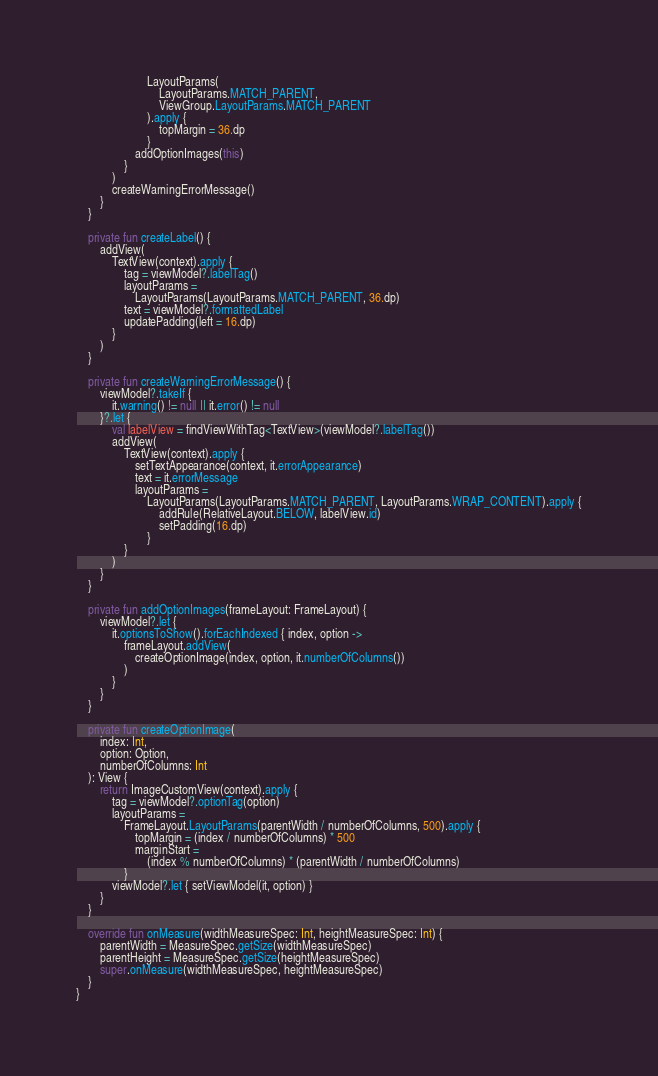Convert code to text. <code><loc_0><loc_0><loc_500><loc_500><_Kotlin_>                        LayoutParams(
                            LayoutParams.MATCH_PARENT,
                            ViewGroup.LayoutParams.MATCH_PARENT
                        ).apply {
                            topMargin = 36.dp
                        }
                    addOptionImages(this)
                }
            )
            createWarningErrorMessage()
        }
    }

    private fun createLabel() {
        addView(
            TextView(context).apply {
                tag = viewModel?.labelTag()
                layoutParams =
                    LayoutParams(LayoutParams.MATCH_PARENT, 36.dp)
                text = viewModel?.formattedLabel
                updatePadding(left = 16.dp)
            }
        )
    }

    private fun createWarningErrorMessage() {
        viewModel?.takeIf {
            it.warning() != null || it.error() != null
        }?.let {
            val labelView = findViewWithTag<TextView>(viewModel?.labelTag())
            addView(
                TextView(context).apply {
                    setTextAppearance(context, it.errorAppearance)
                    text = it.errorMessage
                    layoutParams =
                        LayoutParams(LayoutParams.MATCH_PARENT, LayoutParams.WRAP_CONTENT).apply {
                            addRule(RelativeLayout.BELOW, labelView.id)
                            setPadding(16.dp)
                        }
                }
            )
        }
    }

    private fun addOptionImages(frameLayout: FrameLayout) {
        viewModel?.let {
            it.optionsToShow().forEachIndexed { index, option ->
                frameLayout.addView(
                    createOptionImage(index, option, it.numberOfColumns())
                )
            }
        }
    }

    private fun createOptionImage(
        index: Int,
        option: Option,
        numberOfColumns: Int
    ): View {
        return ImageCustomView(context).apply {
            tag = viewModel?.optionTag(option)
            layoutParams =
                FrameLayout.LayoutParams(parentWidth / numberOfColumns, 500).apply {
                    topMargin = (index / numberOfColumns) * 500
                    marginStart =
                        (index % numberOfColumns) * (parentWidth / numberOfColumns)
                }
            viewModel?.let { setViewModel(it, option) }
        }
    }

    override fun onMeasure(widthMeasureSpec: Int, heightMeasureSpec: Int) {
        parentWidth = MeasureSpec.getSize(widthMeasureSpec)
        parentHeight = MeasureSpec.getSize(heightMeasureSpec)
        super.onMeasure(widthMeasureSpec, heightMeasureSpec)
    }
}
</code> 